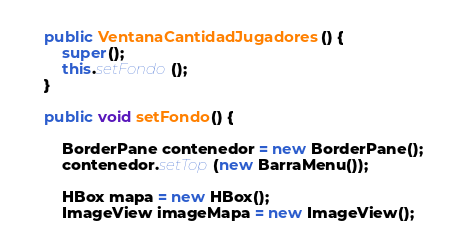<code> <loc_0><loc_0><loc_500><loc_500><_Java_>    public VentanaCantidadJugadores() {
        super();
        this.setFondo();
    }

    public void setFondo() {

        BorderPane contenedor = new BorderPane();
        contenedor.setTop(new BarraMenu());

        HBox mapa = new HBox();
        ImageView imageMapa = new ImageView();</code> 